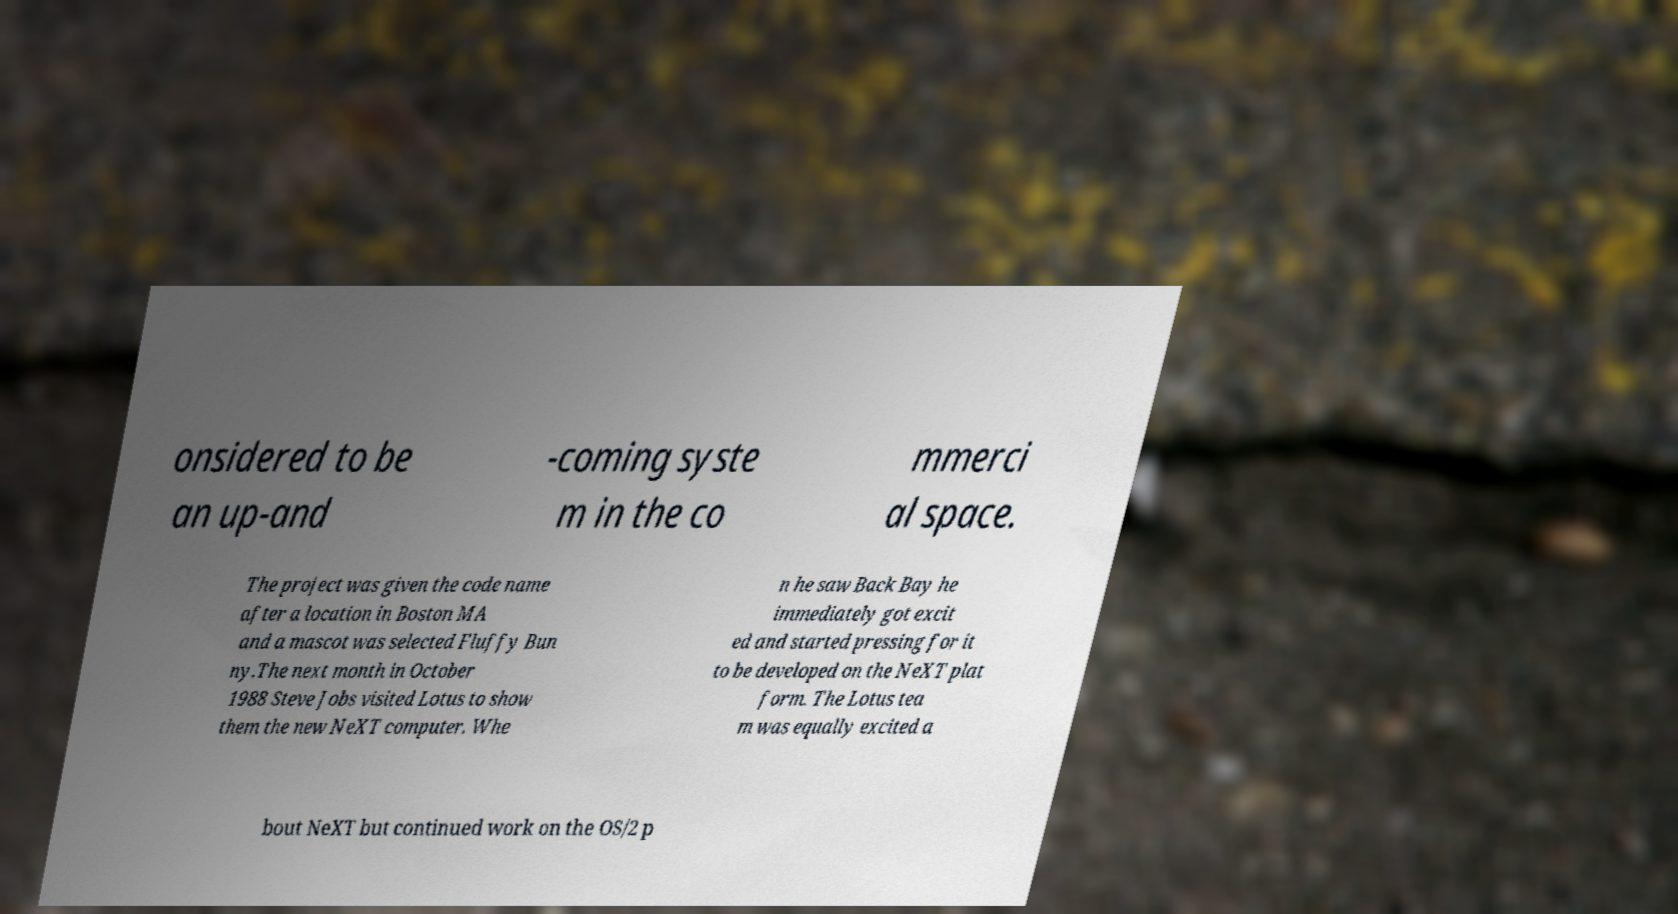I need the written content from this picture converted into text. Can you do that? onsidered to be an up-and -coming syste m in the co mmerci al space. The project was given the code name after a location in Boston MA and a mascot was selected Fluffy Bun ny.The next month in October 1988 Steve Jobs visited Lotus to show them the new NeXT computer. Whe n he saw Back Bay he immediately got excit ed and started pressing for it to be developed on the NeXT plat form. The Lotus tea m was equally excited a bout NeXT but continued work on the OS/2 p 